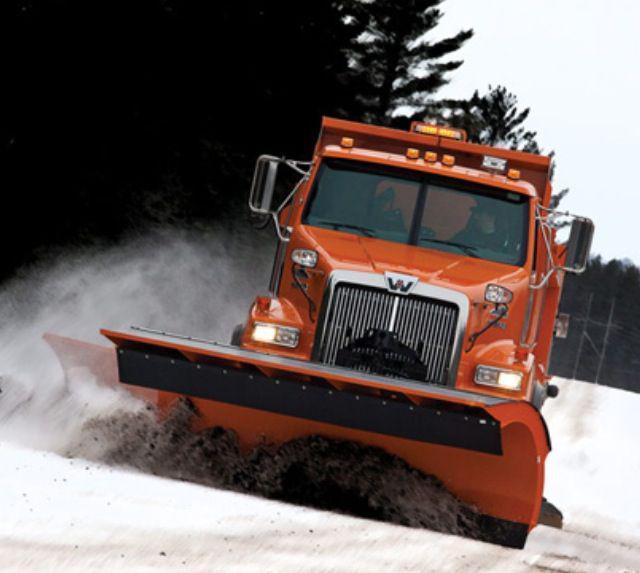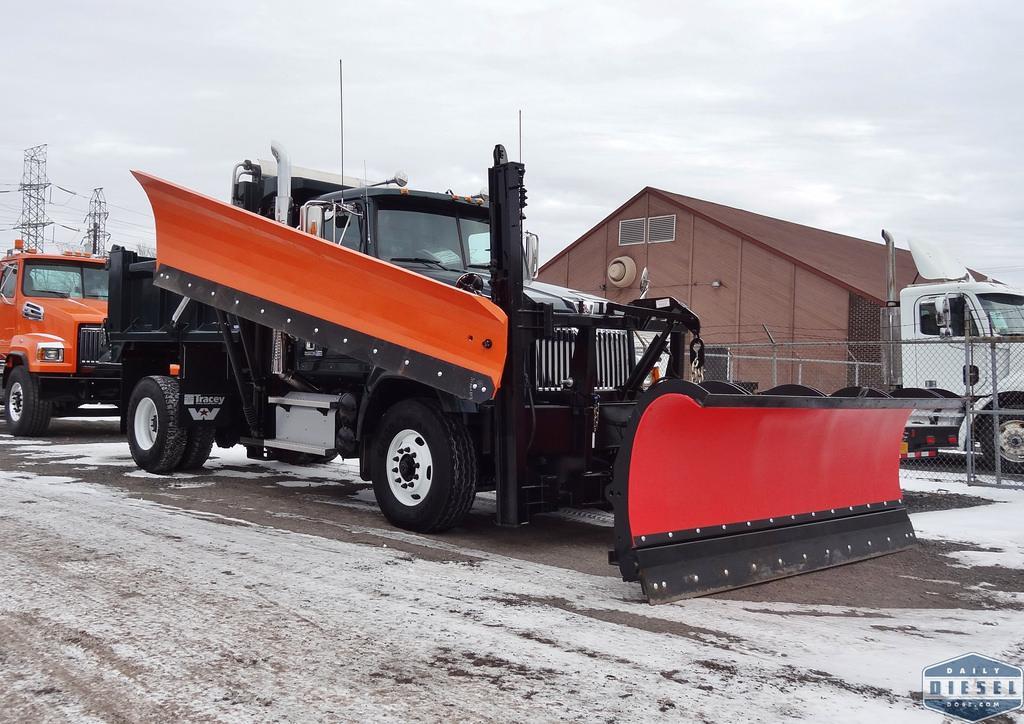The first image is the image on the left, the second image is the image on the right. Assess this claim about the two images: "The truck is passing a building in one of the iamges.". Correct or not? Answer yes or no. Yes. 